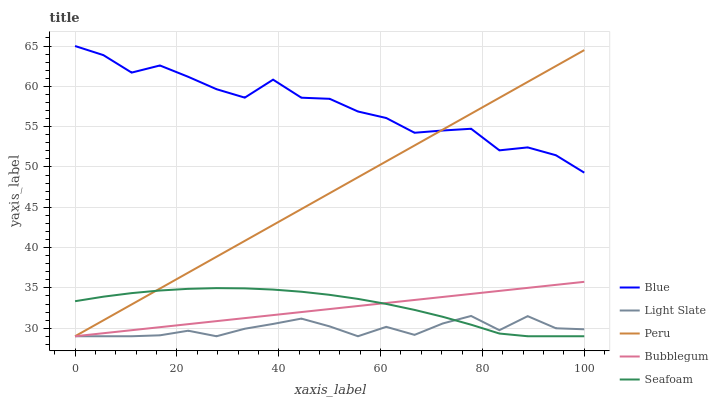Does Light Slate have the minimum area under the curve?
Answer yes or no. Yes. Does Blue have the maximum area under the curve?
Answer yes or no. Yes. Does Bubblegum have the minimum area under the curve?
Answer yes or no. No. Does Bubblegum have the maximum area under the curve?
Answer yes or no. No. Is Peru the smoothest?
Answer yes or no. Yes. Is Blue the roughest?
Answer yes or no. Yes. Is Light Slate the smoothest?
Answer yes or no. No. Is Light Slate the roughest?
Answer yes or no. No. Does Light Slate have the lowest value?
Answer yes or no. Yes. Does Blue have the highest value?
Answer yes or no. Yes. Does Bubblegum have the highest value?
Answer yes or no. No. Is Light Slate less than Blue?
Answer yes or no. Yes. Is Blue greater than Light Slate?
Answer yes or no. Yes. Does Bubblegum intersect Seafoam?
Answer yes or no. Yes. Is Bubblegum less than Seafoam?
Answer yes or no. No. Is Bubblegum greater than Seafoam?
Answer yes or no. No. Does Light Slate intersect Blue?
Answer yes or no. No. 